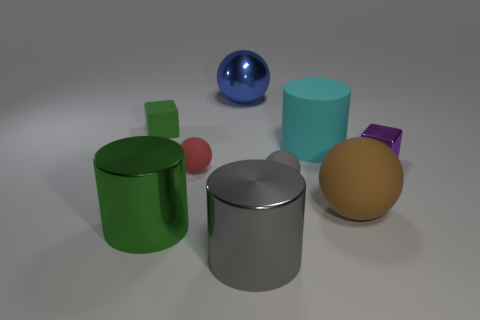Subtract all green spheres. Subtract all red cubes. How many spheres are left? 4 Add 1 large metal objects. How many objects exist? 10 Subtract all blocks. How many objects are left? 7 Subtract 1 gray cylinders. How many objects are left? 8 Subtract all large cyan rubber cylinders. Subtract all brown rubber spheres. How many objects are left? 7 Add 4 matte balls. How many matte balls are left? 7 Add 1 red rubber objects. How many red rubber objects exist? 2 